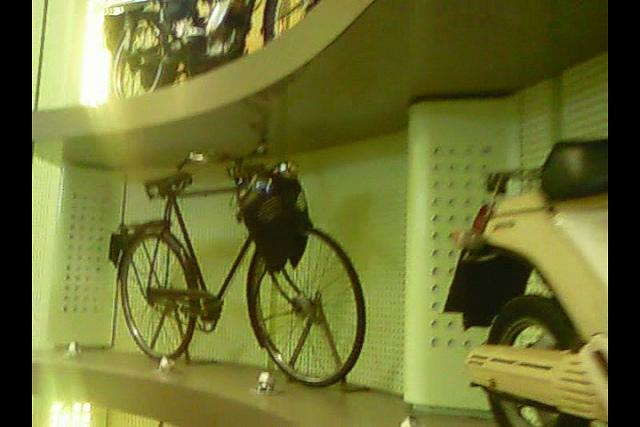What mode of transportation is featured? Please explain your reasoning. bike. It has two wheels with spokes and a small seat and handlebars, consistent with that of a bike 